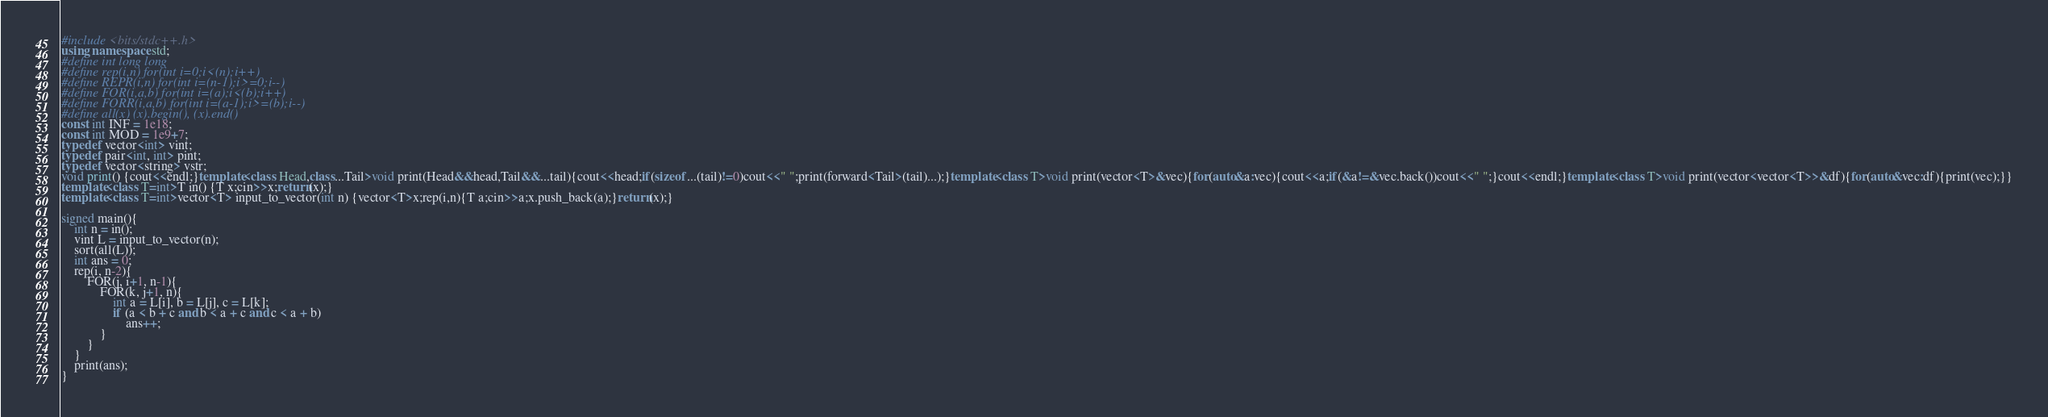<code> <loc_0><loc_0><loc_500><loc_500><_C++_>#include <bits/stdc++.h>
using namespace std;
#define int long long
#define rep(i,n) for(int i=0;i<(n);i++)
#define REPR(i,n) for(int i=(n-1);i>=0;i--)
#define FOR(i,a,b) for(int i=(a);i<(b);i++)
#define FORR(i,a,b) for(int i=(a-1);i>=(b);i--)
#define all(x) (x).begin(), (x).end()
const int INF = 1e18;
const int MOD = 1e9+7;
typedef vector<int> vint;
typedef pair<int, int> pint;
typedef vector<string> vstr;
void print() {cout<<endl;}template<class Head,class...Tail>void print(Head&&head,Tail&&...tail){cout<<head;if(sizeof...(tail)!=0)cout<<" ";print(forward<Tail>(tail)...);}template<class T>void print(vector<T>&vec){for(auto&a:vec){cout<<a;if(&a!=&vec.back())cout<<" ";}cout<<endl;}template<class T>void print(vector<vector<T>>&df){for(auto&vec:df){print(vec);}}
template<class T=int>T in() {T x;cin>>x;return(x);}
template<class T=int>vector<T> input_to_vector(int n) {vector<T>x;rep(i,n){T a;cin>>a;x.push_back(a);}return(x);}

signed main(){
    int n = in();
    vint L = input_to_vector(n);
    sort(all(L));
    int ans = 0;
    rep(i, n-2){
        FOR(j, i+1, n-1){
            FOR(k, j+1, n){
                int a = L[i], b = L[j], c = L[k];
                if (a < b + c and b < a + c and c < a + b)
                    ans++;
            }
        }
    }
    print(ans);
}</code> 